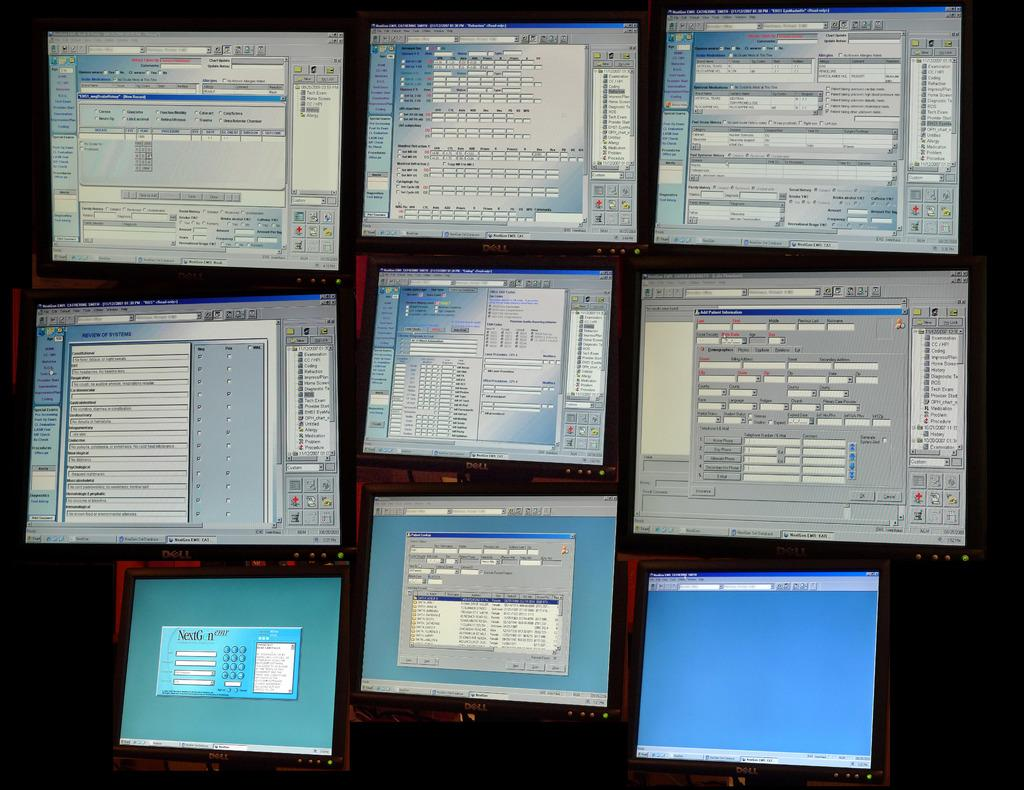What type of furniture is visible in the image? There are desktops in the image. What can be seen on the desktops? There are tabs opened on the desktops. What type of cork can be seen on the desktops in the image? There is no cork present on the desktops in the image. How many wheels are visible on the desktops in the image? The desktops in the image are not depicted as having wheels. 